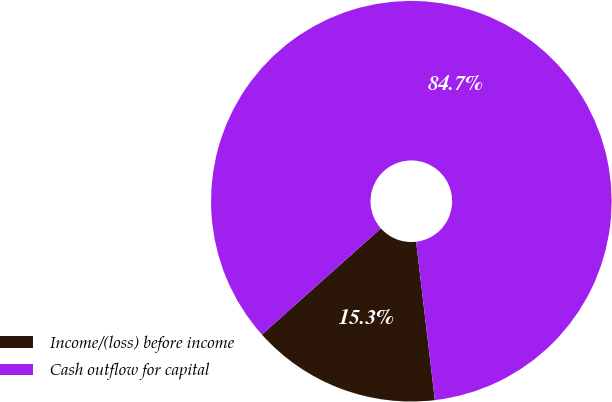Convert chart to OTSL. <chart><loc_0><loc_0><loc_500><loc_500><pie_chart><fcel>Income/(loss) before income<fcel>Cash outflow for capital<nl><fcel>15.28%<fcel>84.72%<nl></chart> 